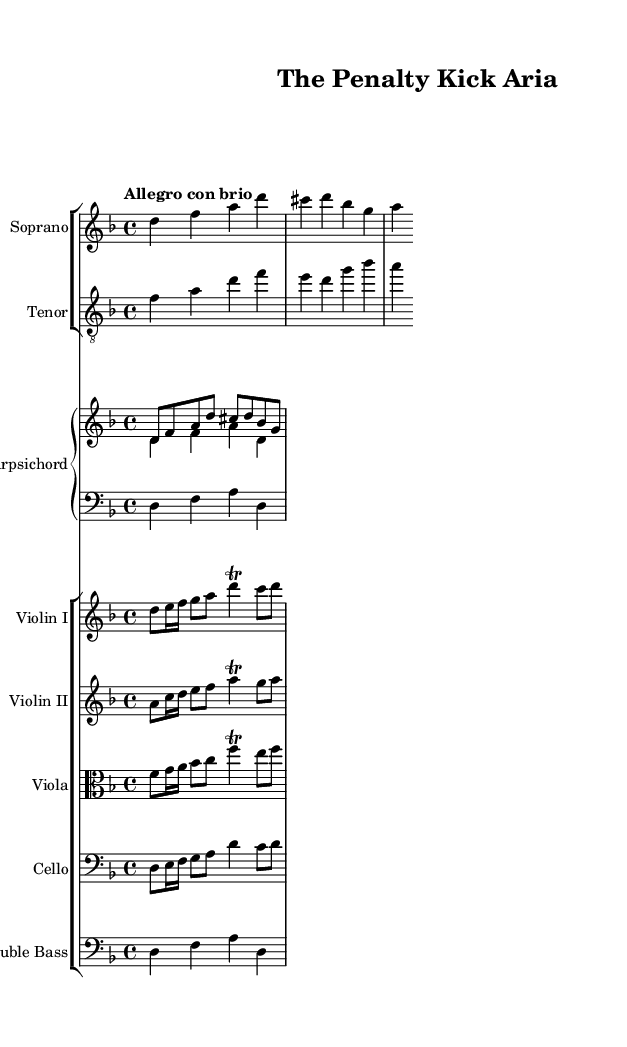What is the key signature of this music? The key signature is indicated by the number of sharps or flats at the beginning of the staff. In this case, the key is D minor, which has one flat (B flat).
Answer: D minor What is the time signature of this music? The time signature is shown at the beginning of the staff, which indicates how many beats are in a measure. Here, it shows 4/4, meaning there are four beats per measure.
Answer: 4/4 What is the tempo marking for this piece? The tempo marking is indicated above the staff, specifying the speed of the music. In this case, it states "Allegro con brio," which denotes a lively tempo.
Answer: Allegro con brio How many instruments are in the ensemble? Counting the different staves, we see there are six different parts (Soprano, Tenor, Harpsichord, Violin I, Violin II, Viola, Cello, and Double Bass). This makes a total of nine instruments.
Answer: Nine What vocal parts are included in this score? The vocal parts are typically indicated by the titles on the staves. Here, we have Soprano and Tenor, which are both traditional vocal parts in Baroque opera.
Answer: Soprano and Tenor What type of composition is represented by this sheet music? By observing the instruments and vocal parts, and the dramatic lyrics that reflect a narrative, this piece reflects a Baroque opera, particularly emulating a dramatic soccer match scenario.
Answer: Baroque opera 